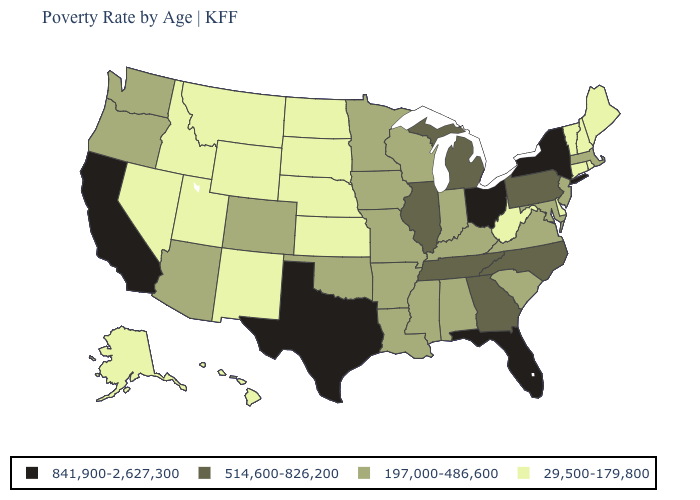Does Florida have the highest value in the South?
Short answer required. Yes. What is the value of Maine?
Quick response, please. 29,500-179,800. Does the first symbol in the legend represent the smallest category?
Be succinct. No. Name the states that have a value in the range 29,500-179,800?
Be succinct. Alaska, Connecticut, Delaware, Hawaii, Idaho, Kansas, Maine, Montana, Nebraska, Nevada, New Hampshire, New Mexico, North Dakota, Rhode Island, South Dakota, Utah, Vermont, West Virginia, Wyoming. Name the states that have a value in the range 197,000-486,600?
Short answer required. Alabama, Arizona, Arkansas, Colorado, Indiana, Iowa, Kentucky, Louisiana, Maryland, Massachusetts, Minnesota, Mississippi, Missouri, New Jersey, Oklahoma, Oregon, South Carolina, Virginia, Washington, Wisconsin. What is the value of Alaska?
Be succinct. 29,500-179,800. Among the states that border Kansas , does Oklahoma have the highest value?
Answer briefly. Yes. Does the first symbol in the legend represent the smallest category?
Concise answer only. No. What is the value of Delaware?
Give a very brief answer. 29,500-179,800. Which states have the lowest value in the USA?
Give a very brief answer. Alaska, Connecticut, Delaware, Hawaii, Idaho, Kansas, Maine, Montana, Nebraska, Nevada, New Hampshire, New Mexico, North Dakota, Rhode Island, South Dakota, Utah, Vermont, West Virginia, Wyoming. Name the states that have a value in the range 29,500-179,800?
Be succinct. Alaska, Connecticut, Delaware, Hawaii, Idaho, Kansas, Maine, Montana, Nebraska, Nevada, New Hampshire, New Mexico, North Dakota, Rhode Island, South Dakota, Utah, Vermont, West Virginia, Wyoming. Name the states that have a value in the range 29,500-179,800?
Answer briefly. Alaska, Connecticut, Delaware, Hawaii, Idaho, Kansas, Maine, Montana, Nebraska, Nevada, New Hampshire, New Mexico, North Dakota, Rhode Island, South Dakota, Utah, Vermont, West Virginia, Wyoming. What is the lowest value in states that border Montana?
Give a very brief answer. 29,500-179,800. What is the highest value in the South ?
Short answer required. 841,900-2,627,300. Name the states that have a value in the range 514,600-826,200?
Be succinct. Georgia, Illinois, Michigan, North Carolina, Pennsylvania, Tennessee. 